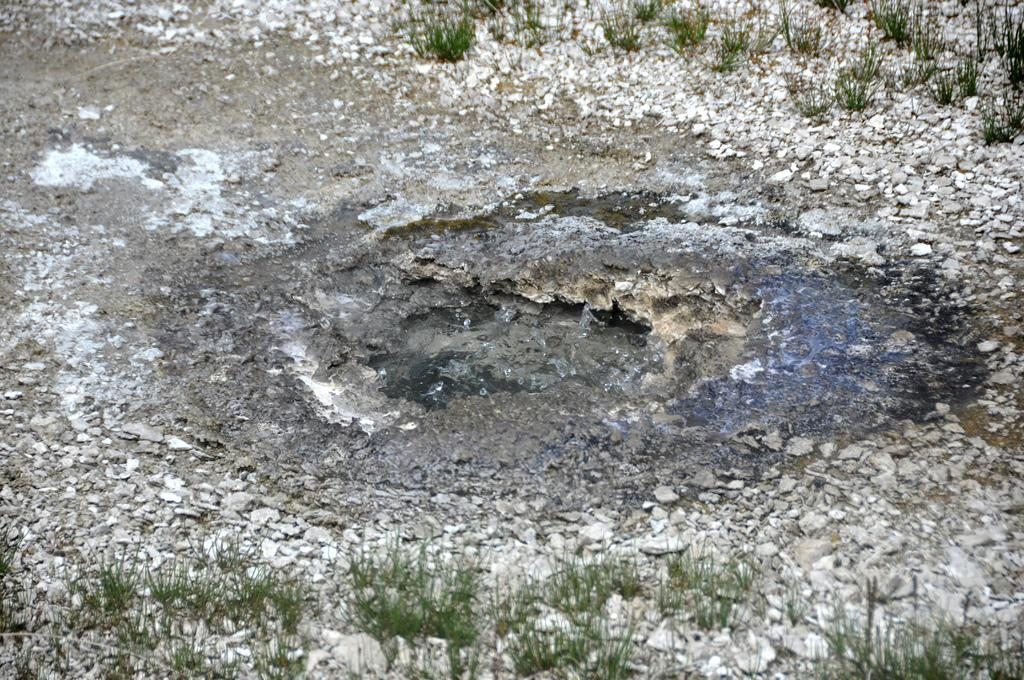What is the primary element visible in the image? There is water in the image. What other objects or features can be seen in the image? There are stones and grass visible in the image. What type of credit card is being used in the image? There is no credit card present in the image. How does the disease affect the grass in the image? There is no disease present in the image, and the grass appears healthy. 